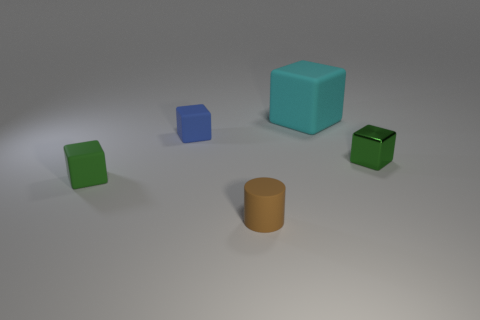Is the color of the thing to the right of the cyan object the same as the matte object that is on the right side of the tiny brown rubber cylinder?
Give a very brief answer. No. The blue thing that is the same size as the green shiny thing is what shape?
Keep it short and to the point. Cube. How many things are cubes to the right of the cyan thing or matte cubes to the left of the tiny green shiny cube?
Ensure brevity in your answer.  4. Is the number of brown shiny blocks less than the number of small brown rubber cylinders?
Offer a very short reply. Yes. There is a blue cube that is the same size as the brown object; what is its material?
Your response must be concise. Rubber. There is a cube that is in front of the green metallic block; is it the same size as the matte object right of the tiny brown cylinder?
Keep it short and to the point. No. Is there a green thing made of the same material as the cyan cube?
Provide a short and direct response. Yes. How many things are objects that are in front of the tiny blue matte block or big gray metallic cubes?
Make the answer very short. 3. Is the material of the green cube that is to the left of the large cyan rubber cube the same as the tiny brown object?
Make the answer very short. Yes. Is the blue matte thing the same shape as the green shiny thing?
Your response must be concise. Yes. 